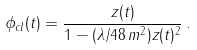<formula> <loc_0><loc_0><loc_500><loc_500>\phi _ { c l } ( t ) = { \frac { z ( t ) } { 1 - ( \lambda / 4 8 \, m ^ { 2 } ) z ( t ) ^ { 2 } } } \, .</formula> 